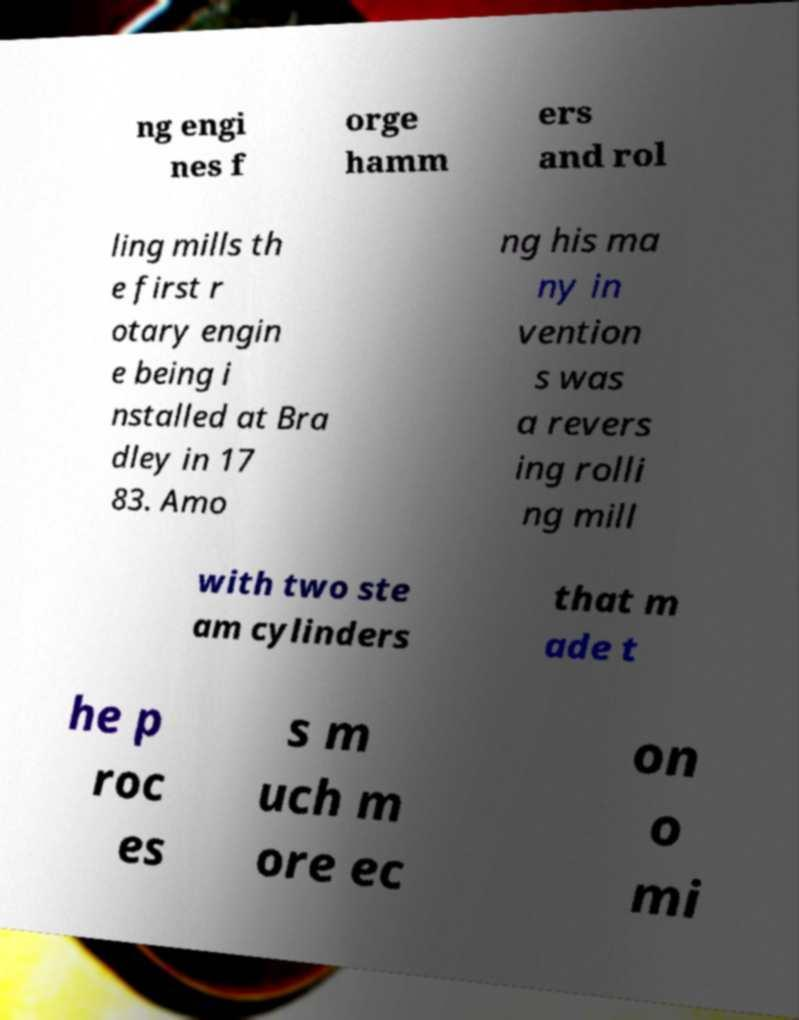Please read and relay the text visible in this image. What does it say? ng engi nes f orge hamm ers and rol ling mills th e first r otary engin e being i nstalled at Bra dley in 17 83. Amo ng his ma ny in vention s was a revers ing rolli ng mill with two ste am cylinders that m ade t he p roc es s m uch m ore ec on o mi 